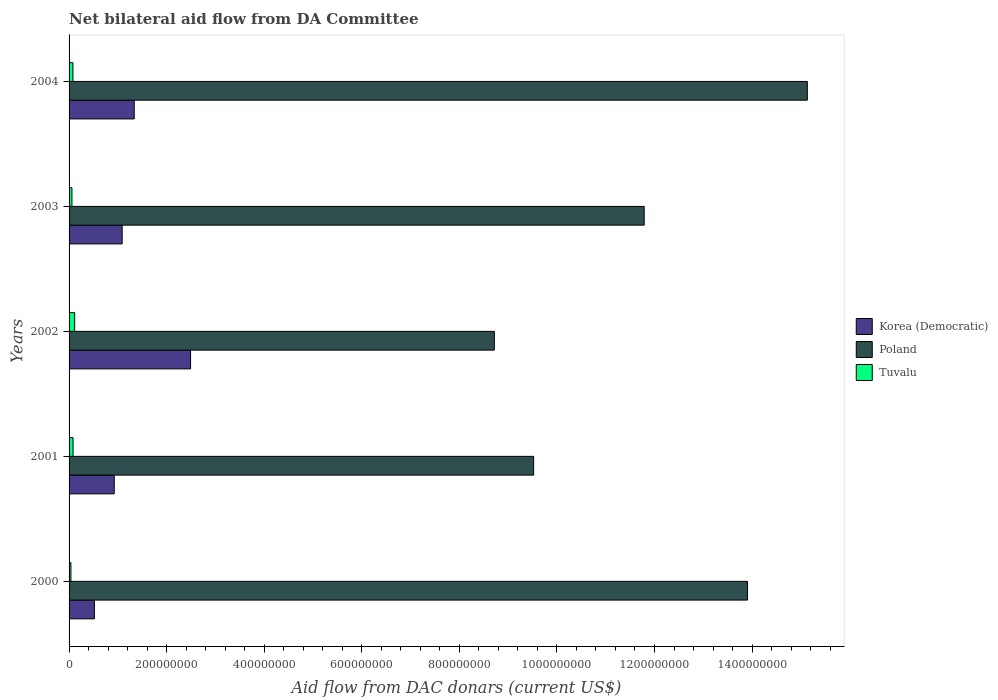How many different coloured bars are there?
Keep it short and to the point. 3. How many groups of bars are there?
Offer a terse response. 5. How many bars are there on the 3rd tick from the top?
Offer a very short reply. 3. What is the aid flow in in Poland in 2003?
Offer a terse response. 1.18e+09. Across all years, what is the maximum aid flow in in Tuvalu?
Offer a very short reply. 1.15e+07. Across all years, what is the minimum aid flow in in Poland?
Your response must be concise. 8.72e+08. In which year was the aid flow in in Poland maximum?
Keep it short and to the point. 2004. In which year was the aid flow in in Tuvalu minimum?
Provide a short and direct response. 2000. What is the total aid flow in in Tuvalu in the graph?
Offer a very short reply. 3.72e+07. What is the difference between the aid flow in in Korea (Democratic) in 2002 and that in 2004?
Keep it short and to the point. 1.15e+08. What is the difference between the aid flow in in Tuvalu in 2004 and the aid flow in in Poland in 2001?
Make the answer very short. -9.44e+08. What is the average aid flow in in Korea (Democratic) per year?
Offer a very short reply. 1.27e+08. In the year 2004, what is the difference between the aid flow in in Poland and aid flow in in Tuvalu?
Provide a short and direct response. 1.51e+09. What is the ratio of the aid flow in in Korea (Democratic) in 2001 to that in 2003?
Make the answer very short. 0.85. Is the aid flow in in Tuvalu in 2000 less than that in 2004?
Provide a short and direct response. Yes. What is the difference between the highest and the second highest aid flow in in Tuvalu?
Ensure brevity in your answer.  3.33e+06. What is the difference between the highest and the lowest aid flow in in Poland?
Your answer should be very brief. 6.42e+08. Is the sum of the aid flow in in Korea (Democratic) in 2001 and 2004 greater than the maximum aid flow in in Tuvalu across all years?
Make the answer very short. Yes. What does the 1st bar from the top in 2000 represents?
Provide a succinct answer. Tuvalu. Is it the case that in every year, the sum of the aid flow in in Korea (Democratic) and aid flow in in Poland is greater than the aid flow in in Tuvalu?
Provide a succinct answer. Yes. How many bars are there?
Your answer should be very brief. 15. Are the values on the major ticks of X-axis written in scientific E-notation?
Offer a very short reply. No. Does the graph contain any zero values?
Ensure brevity in your answer.  No. Where does the legend appear in the graph?
Ensure brevity in your answer.  Center right. What is the title of the graph?
Provide a short and direct response. Net bilateral aid flow from DA Committee. Does "Suriname" appear as one of the legend labels in the graph?
Offer a terse response. No. What is the label or title of the X-axis?
Make the answer very short. Aid flow from DAC donars (current US$). What is the Aid flow from DAC donars (current US$) of Korea (Democratic) in 2000?
Your response must be concise. 5.19e+07. What is the Aid flow from DAC donars (current US$) in Poland in 2000?
Your answer should be compact. 1.39e+09. What is the Aid flow from DAC donars (current US$) in Tuvalu in 2000?
Offer a terse response. 3.81e+06. What is the Aid flow from DAC donars (current US$) in Korea (Democratic) in 2001?
Offer a very short reply. 9.26e+07. What is the Aid flow from DAC donars (current US$) in Poland in 2001?
Provide a succinct answer. 9.52e+08. What is the Aid flow from DAC donars (current US$) of Tuvalu in 2001?
Your response must be concise. 8.14e+06. What is the Aid flow from DAC donars (current US$) of Korea (Democratic) in 2002?
Offer a very short reply. 2.49e+08. What is the Aid flow from DAC donars (current US$) of Poland in 2002?
Your answer should be very brief. 8.72e+08. What is the Aid flow from DAC donars (current US$) in Tuvalu in 2002?
Offer a very short reply. 1.15e+07. What is the Aid flow from DAC donars (current US$) of Korea (Democratic) in 2003?
Provide a short and direct response. 1.09e+08. What is the Aid flow from DAC donars (current US$) of Poland in 2003?
Your answer should be very brief. 1.18e+09. What is the Aid flow from DAC donars (current US$) in Tuvalu in 2003?
Offer a terse response. 5.89e+06. What is the Aid flow from DAC donars (current US$) of Korea (Democratic) in 2004?
Provide a short and direct response. 1.34e+08. What is the Aid flow from DAC donars (current US$) of Poland in 2004?
Your answer should be very brief. 1.51e+09. What is the Aid flow from DAC donars (current US$) of Tuvalu in 2004?
Provide a short and direct response. 7.89e+06. Across all years, what is the maximum Aid flow from DAC donars (current US$) in Korea (Democratic)?
Provide a short and direct response. 2.49e+08. Across all years, what is the maximum Aid flow from DAC donars (current US$) of Poland?
Provide a short and direct response. 1.51e+09. Across all years, what is the maximum Aid flow from DAC donars (current US$) in Tuvalu?
Provide a succinct answer. 1.15e+07. Across all years, what is the minimum Aid flow from DAC donars (current US$) of Korea (Democratic)?
Offer a terse response. 5.19e+07. Across all years, what is the minimum Aid flow from DAC donars (current US$) of Poland?
Give a very brief answer. 8.72e+08. Across all years, what is the minimum Aid flow from DAC donars (current US$) of Tuvalu?
Ensure brevity in your answer.  3.81e+06. What is the total Aid flow from DAC donars (current US$) of Korea (Democratic) in the graph?
Offer a terse response. 6.36e+08. What is the total Aid flow from DAC donars (current US$) in Poland in the graph?
Offer a very short reply. 5.91e+09. What is the total Aid flow from DAC donars (current US$) of Tuvalu in the graph?
Provide a succinct answer. 3.72e+07. What is the difference between the Aid flow from DAC donars (current US$) of Korea (Democratic) in 2000 and that in 2001?
Your response must be concise. -4.07e+07. What is the difference between the Aid flow from DAC donars (current US$) of Poland in 2000 and that in 2001?
Your answer should be compact. 4.38e+08. What is the difference between the Aid flow from DAC donars (current US$) of Tuvalu in 2000 and that in 2001?
Your response must be concise. -4.33e+06. What is the difference between the Aid flow from DAC donars (current US$) in Korea (Democratic) in 2000 and that in 2002?
Give a very brief answer. -1.97e+08. What is the difference between the Aid flow from DAC donars (current US$) of Poland in 2000 and that in 2002?
Provide a short and direct response. 5.19e+08. What is the difference between the Aid flow from DAC donars (current US$) in Tuvalu in 2000 and that in 2002?
Provide a succinct answer. -7.66e+06. What is the difference between the Aid flow from DAC donars (current US$) of Korea (Democratic) in 2000 and that in 2003?
Offer a very short reply. -5.69e+07. What is the difference between the Aid flow from DAC donars (current US$) of Poland in 2000 and that in 2003?
Give a very brief answer. 2.12e+08. What is the difference between the Aid flow from DAC donars (current US$) in Tuvalu in 2000 and that in 2003?
Offer a terse response. -2.08e+06. What is the difference between the Aid flow from DAC donars (current US$) of Korea (Democratic) in 2000 and that in 2004?
Keep it short and to the point. -8.16e+07. What is the difference between the Aid flow from DAC donars (current US$) of Poland in 2000 and that in 2004?
Your answer should be compact. -1.23e+08. What is the difference between the Aid flow from DAC donars (current US$) in Tuvalu in 2000 and that in 2004?
Your answer should be compact. -4.08e+06. What is the difference between the Aid flow from DAC donars (current US$) in Korea (Democratic) in 2001 and that in 2002?
Keep it short and to the point. -1.56e+08. What is the difference between the Aid flow from DAC donars (current US$) in Poland in 2001 and that in 2002?
Offer a very short reply. 8.06e+07. What is the difference between the Aid flow from DAC donars (current US$) of Tuvalu in 2001 and that in 2002?
Your answer should be very brief. -3.33e+06. What is the difference between the Aid flow from DAC donars (current US$) of Korea (Democratic) in 2001 and that in 2003?
Keep it short and to the point. -1.62e+07. What is the difference between the Aid flow from DAC donars (current US$) of Poland in 2001 and that in 2003?
Ensure brevity in your answer.  -2.27e+08. What is the difference between the Aid flow from DAC donars (current US$) of Tuvalu in 2001 and that in 2003?
Offer a very short reply. 2.25e+06. What is the difference between the Aid flow from DAC donars (current US$) of Korea (Democratic) in 2001 and that in 2004?
Make the answer very short. -4.10e+07. What is the difference between the Aid flow from DAC donars (current US$) in Poland in 2001 and that in 2004?
Provide a short and direct response. -5.61e+08. What is the difference between the Aid flow from DAC donars (current US$) in Korea (Democratic) in 2002 and that in 2003?
Your answer should be compact. 1.40e+08. What is the difference between the Aid flow from DAC donars (current US$) in Poland in 2002 and that in 2003?
Offer a terse response. -3.07e+08. What is the difference between the Aid flow from DAC donars (current US$) in Tuvalu in 2002 and that in 2003?
Give a very brief answer. 5.58e+06. What is the difference between the Aid flow from DAC donars (current US$) in Korea (Democratic) in 2002 and that in 2004?
Offer a very short reply. 1.15e+08. What is the difference between the Aid flow from DAC donars (current US$) in Poland in 2002 and that in 2004?
Offer a very short reply. -6.42e+08. What is the difference between the Aid flow from DAC donars (current US$) of Tuvalu in 2002 and that in 2004?
Your answer should be very brief. 3.58e+06. What is the difference between the Aid flow from DAC donars (current US$) of Korea (Democratic) in 2003 and that in 2004?
Offer a very short reply. -2.47e+07. What is the difference between the Aid flow from DAC donars (current US$) in Poland in 2003 and that in 2004?
Give a very brief answer. -3.34e+08. What is the difference between the Aid flow from DAC donars (current US$) in Tuvalu in 2003 and that in 2004?
Provide a short and direct response. -2.00e+06. What is the difference between the Aid flow from DAC donars (current US$) in Korea (Democratic) in 2000 and the Aid flow from DAC donars (current US$) in Poland in 2001?
Your response must be concise. -9.00e+08. What is the difference between the Aid flow from DAC donars (current US$) of Korea (Democratic) in 2000 and the Aid flow from DAC donars (current US$) of Tuvalu in 2001?
Give a very brief answer. 4.38e+07. What is the difference between the Aid flow from DAC donars (current US$) in Poland in 2000 and the Aid flow from DAC donars (current US$) in Tuvalu in 2001?
Keep it short and to the point. 1.38e+09. What is the difference between the Aid flow from DAC donars (current US$) in Korea (Democratic) in 2000 and the Aid flow from DAC donars (current US$) in Poland in 2002?
Give a very brief answer. -8.20e+08. What is the difference between the Aid flow from DAC donars (current US$) in Korea (Democratic) in 2000 and the Aid flow from DAC donars (current US$) in Tuvalu in 2002?
Make the answer very short. 4.05e+07. What is the difference between the Aid flow from DAC donars (current US$) of Poland in 2000 and the Aid flow from DAC donars (current US$) of Tuvalu in 2002?
Offer a terse response. 1.38e+09. What is the difference between the Aid flow from DAC donars (current US$) in Korea (Democratic) in 2000 and the Aid flow from DAC donars (current US$) in Poland in 2003?
Make the answer very short. -1.13e+09. What is the difference between the Aid flow from DAC donars (current US$) of Korea (Democratic) in 2000 and the Aid flow from DAC donars (current US$) of Tuvalu in 2003?
Keep it short and to the point. 4.60e+07. What is the difference between the Aid flow from DAC donars (current US$) of Poland in 2000 and the Aid flow from DAC donars (current US$) of Tuvalu in 2003?
Offer a very short reply. 1.38e+09. What is the difference between the Aid flow from DAC donars (current US$) in Korea (Democratic) in 2000 and the Aid flow from DAC donars (current US$) in Poland in 2004?
Ensure brevity in your answer.  -1.46e+09. What is the difference between the Aid flow from DAC donars (current US$) of Korea (Democratic) in 2000 and the Aid flow from DAC donars (current US$) of Tuvalu in 2004?
Your answer should be very brief. 4.40e+07. What is the difference between the Aid flow from DAC donars (current US$) in Poland in 2000 and the Aid flow from DAC donars (current US$) in Tuvalu in 2004?
Your response must be concise. 1.38e+09. What is the difference between the Aid flow from DAC donars (current US$) of Korea (Democratic) in 2001 and the Aid flow from DAC donars (current US$) of Poland in 2002?
Ensure brevity in your answer.  -7.79e+08. What is the difference between the Aid flow from DAC donars (current US$) of Korea (Democratic) in 2001 and the Aid flow from DAC donars (current US$) of Tuvalu in 2002?
Offer a very short reply. 8.11e+07. What is the difference between the Aid flow from DAC donars (current US$) in Poland in 2001 and the Aid flow from DAC donars (current US$) in Tuvalu in 2002?
Ensure brevity in your answer.  9.41e+08. What is the difference between the Aid flow from DAC donars (current US$) of Korea (Democratic) in 2001 and the Aid flow from DAC donars (current US$) of Poland in 2003?
Give a very brief answer. -1.09e+09. What is the difference between the Aid flow from DAC donars (current US$) in Korea (Democratic) in 2001 and the Aid flow from DAC donars (current US$) in Tuvalu in 2003?
Your answer should be very brief. 8.67e+07. What is the difference between the Aid flow from DAC donars (current US$) of Poland in 2001 and the Aid flow from DAC donars (current US$) of Tuvalu in 2003?
Your response must be concise. 9.46e+08. What is the difference between the Aid flow from DAC donars (current US$) of Korea (Democratic) in 2001 and the Aid flow from DAC donars (current US$) of Poland in 2004?
Provide a succinct answer. -1.42e+09. What is the difference between the Aid flow from DAC donars (current US$) in Korea (Democratic) in 2001 and the Aid flow from DAC donars (current US$) in Tuvalu in 2004?
Offer a terse response. 8.47e+07. What is the difference between the Aid flow from DAC donars (current US$) in Poland in 2001 and the Aid flow from DAC donars (current US$) in Tuvalu in 2004?
Give a very brief answer. 9.44e+08. What is the difference between the Aid flow from DAC donars (current US$) in Korea (Democratic) in 2002 and the Aid flow from DAC donars (current US$) in Poland in 2003?
Give a very brief answer. -9.30e+08. What is the difference between the Aid flow from DAC donars (current US$) in Korea (Democratic) in 2002 and the Aid flow from DAC donars (current US$) in Tuvalu in 2003?
Provide a short and direct response. 2.43e+08. What is the difference between the Aid flow from DAC donars (current US$) of Poland in 2002 and the Aid flow from DAC donars (current US$) of Tuvalu in 2003?
Offer a terse response. 8.66e+08. What is the difference between the Aid flow from DAC donars (current US$) of Korea (Democratic) in 2002 and the Aid flow from DAC donars (current US$) of Poland in 2004?
Your response must be concise. -1.26e+09. What is the difference between the Aid flow from DAC donars (current US$) of Korea (Democratic) in 2002 and the Aid flow from DAC donars (current US$) of Tuvalu in 2004?
Your response must be concise. 2.41e+08. What is the difference between the Aid flow from DAC donars (current US$) of Poland in 2002 and the Aid flow from DAC donars (current US$) of Tuvalu in 2004?
Offer a terse response. 8.64e+08. What is the difference between the Aid flow from DAC donars (current US$) in Korea (Democratic) in 2003 and the Aid flow from DAC donars (current US$) in Poland in 2004?
Provide a succinct answer. -1.40e+09. What is the difference between the Aid flow from DAC donars (current US$) in Korea (Democratic) in 2003 and the Aid flow from DAC donars (current US$) in Tuvalu in 2004?
Ensure brevity in your answer.  1.01e+08. What is the difference between the Aid flow from DAC donars (current US$) in Poland in 2003 and the Aid flow from DAC donars (current US$) in Tuvalu in 2004?
Ensure brevity in your answer.  1.17e+09. What is the average Aid flow from DAC donars (current US$) in Korea (Democratic) per year?
Your answer should be compact. 1.27e+08. What is the average Aid flow from DAC donars (current US$) of Poland per year?
Offer a very short reply. 1.18e+09. What is the average Aid flow from DAC donars (current US$) of Tuvalu per year?
Keep it short and to the point. 7.44e+06. In the year 2000, what is the difference between the Aid flow from DAC donars (current US$) of Korea (Democratic) and Aid flow from DAC donars (current US$) of Poland?
Make the answer very short. -1.34e+09. In the year 2000, what is the difference between the Aid flow from DAC donars (current US$) in Korea (Democratic) and Aid flow from DAC donars (current US$) in Tuvalu?
Offer a very short reply. 4.81e+07. In the year 2000, what is the difference between the Aid flow from DAC donars (current US$) of Poland and Aid flow from DAC donars (current US$) of Tuvalu?
Ensure brevity in your answer.  1.39e+09. In the year 2001, what is the difference between the Aid flow from DAC donars (current US$) in Korea (Democratic) and Aid flow from DAC donars (current US$) in Poland?
Make the answer very short. -8.60e+08. In the year 2001, what is the difference between the Aid flow from DAC donars (current US$) in Korea (Democratic) and Aid flow from DAC donars (current US$) in Tuvalu?
Ensure brevity in your answer.  8.45e+07. In the year 2001, what is the difference between the Aid flow from DAC donars (current US$) of Poland and Aid flow from DAC donars (current US$) of Tuvalu?
Give a very brief answer. 9.44e+08. In the year 2002, what is the difference between the Aid flow from DAC donars (current US$) in Korea (Democratic) and Aid flow from DAC donars (current US$) in Poland?
Provide a succinct answer. -6.23e+08. In the year 2002, what is the difference between the Aid flow from DAC donars (current US$) in Korea (Democratic) and Aid flow from DAC donars (current US$) in Tuvalu?
Your response must be concise. 2.38e+08. In the year 2002, what is the difference between the Aid flow from DAC donars (current US$) of Poland and Aid flow from DAC donars (current US$) of Tuvalu?
Give a very brief answer. 8.60e+08. In the year 2003, what is the difference between the Aid flow from DAC donars (current US$) in Korea (Democratic) and Aid flow from DAC donars (current US$) in Poland?
Make the answer very short. -1.07e+09. In the year 2003, what is the difference between the Aid flow from DAC donars (current US$) in Korea (Democratic) and Aid flow from DAC donars (current US$) in Tuvalu?
Offer a terse response. 1.03e+08. In the year 2003, what is the difference between the Aid flow from DAC donars (current US$) of Poland and Aid flow from DAC donars (current US$) of Tuvalu?
Your response must be concise. 1.17e+09. In the year 2004, what is the difference between the Aid flow from DAC donars (current US$) in Korea (Democratic) and Aid flow from DAC donars (current US$) in Poland?
Offer a terse response. -1.38e+09. In the year 2004, what is the difference between the Aid flow from DAC donars (current US$) in Korea (Democratic) and Aid flow from DAC donars (current US$) in Tuvalu?
Provide a succinct answer. 1.26e+08. In the year 2004, what is the difference between the Aid flow from DAC donars (current US$) in Poland and Aid flow from DAC donars (current US$) in Tuvalu?
Offer a terse response. 1.51e+09. What is the ratio of the Aid flow from DAC donars (current US$) in Korea (Democratic) in 2000 to that in 2001?
Your response must be concise. 0.56. What is the ratio of the Aid flow from DAC donars (current US$) of Poland in 2000 to that in 2001?
Give a very brief answer. 1.46. What is the ratio of the Aid flow from DAC donars (current US$) of Tuvalu in 2000 to that in 2001?
Your answer should be very brief. 0.47. What is the ratio of the Aid flow from DAC donars (current US$) of Korea (Democratic) in 2000 to that in 2002?
Provide a short and direct response. 0.21. What is the ratio of the Aid flow from DAC donars (current US$) in Poland in 2000 to that in 2002?
Your answer should be compact. 1.6. What is the ratio of the Aid flow from DAC donars (current US$) in Tuvalu in 2000 to that in 2002?
Provide a succinct answer. 0.33. What is the ratio of the Aid flow from DAC donars (current US$) in Korea (Democratic) in 2000 to that in 2003?
Offer a terse response. 0.48. What is the ratio of the Aid flow from DAC donars (current US$) of Poland in 2000 to that in 2003?
Offer a terse response. 1.18. What is the ratio of the Aid flow from DAC donars (current US$) in Tuvalu in 2000 to that in 2003?
Provide a succinct answer. 0.65. What is the ratio of the Aid flow from DAC donars (current US$) of Korea (Democratic) in 2000 to that in 2004?
Offer a terse response. 0.39. What is the ratio of the Aid flow from DAC donars (current US$) in Poland in 2000 to that in 2004?
Provide a short and direct response. 0.92. What is the ratio of the Aid flow from DAC donars (current US$) of Tuvalu in 2000 to that in 2004?
Keep it short and to the point. 0.48. What is the ratio of the Aid flow from DAC donars (current US$) of Korea (Democratic) in 2001 to that in 2002?
Make the answer very short. 0.37. What is the ratio of the Aid flow from DAC donars (current US$) in Poland in 2001 to that in 2002?
Make the answer very short. 1.09. What is the ratio of the Aid flow from DAC donars (current US$) in Tuvalu in 2001 to that in 2002?
Keep it short and to the point. 0.71. What is the ratio of the Aid flow from DAC donars (current US$) in Korea (Democratic) in 2001 to that in 2003?
Ensure brevity in your answer.  0.85. What is the ratio of the Aid flow from DAC donars (current US$) in Poland in 2001 to that in 2003?
Offer a very short reply. 0.81. What is the ratio of the Aid flow from DAC donars (current US$) of Tuvalu in 2001 to that in 2003?
Make the answer very short. 1.38. What is the ratio of the Aid flow from DAC donars (current US$) in Korea (Democratic) in 2001 to that in 2004?
Provide a succinct answer. 0.69. What is the ratio of the Aid flow from DAC donars (current US$) of Poland in 2001 to that in 2004?
Your answer should be very brief. 0.63. What is the ratio of the Aid flow from DAC donars (current US$) of Tuvalu in 2001 to that in 2004?
Your answer should be compact. 1.03. What is the ratio of the Aid flow from DAC donars (current US$) of Korea (Democratic) in 2002 to that in 2003?
Give a very brief answer. 2.29. What is the ratio of the Aid flow from DAC donars (current US$) of Poland in 2002 to that in 2003?
Offer a very short reply. 0.74. What is the ratio of the Aid flow from DAC donars (current US$) in Tuvalu in 2002 to that in 2003?
Provide a succinct answer. 1.95. What is the ratio of the Aid flow from DAC donars (current US$) of Korea (Democratic) in 2002 to that in 2004?
Your answer should be compact. 1.86. What is the ratio of the Aid flow from DAC donars (current US$) in Poland in 2002 to that in 2004?
Offer a very short reply. 0.58. What is the ratio of the Aid flow from DAC donars (current US$) in Tuvalu in 2002 to that in 2004?
Your answer should be very brief. 1.45. What is the ratio of the Aid flow from DAC donars (current US$) of Korea (Democratic) in 2003 to that in 2004?
Offer a very short reply. 0.81. What is the ratio of the Aid flow from DAC donars (current US$) of Poland in 2003 to that in 2004?
Keep it short and to the point. 0.78. What is the ratio of the Aid flow from DAC donars (current US$) in Tuvalu in 2003 to that in 2004?
Offer a terse response. 0.75. What is the difference between the highest and the second highest Aid flow from DAC donars (current US$) of Korea (Democratic)?
Offer a terse response. 1.15e+08. What is the difference between the highest and the second highest Aid flow from DAC donars (current US$) in Poland?
Your answer should be compact. 1.23e+08. What is the difference between the highest and the second highest Aid flow from DAC donars (current US$) of Tuvalu?
Your response must be concise. 3.33e+06. What is the difference between the highest and the lowest Aid flow from DAC donars (current US$) of Korea (Democratic)?
Give a very brief answer. 1.97e+08. What is the difference between the highest and the lowest Aid flow from DAC donars (current US$) in Poland?
Provide a short and direct response. 6.42e+08. What is the difference between the highest and the lowest Aid flow from DAC donars (current US$) in Tuvalu?
Give a very brief answer. 7.66e+06. 